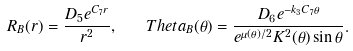<formula> <loc_0><loc_0><loc_500><loc_500>R _ { B } ( r ) = \frac { D _ { 5 } e ^ { C _ { 7 } r } } { r ^ { 2 } } , \quad T h e t a _ { B } ( \theta ) = \frac { D _ { 6 } e ^ { - k _ { 3 } C _ { 7 } \theta } } { e ^ { \mu ( \theta ) / 2 } K ^ { 2 } ( \theta ) \sin \theta } .</formula> 